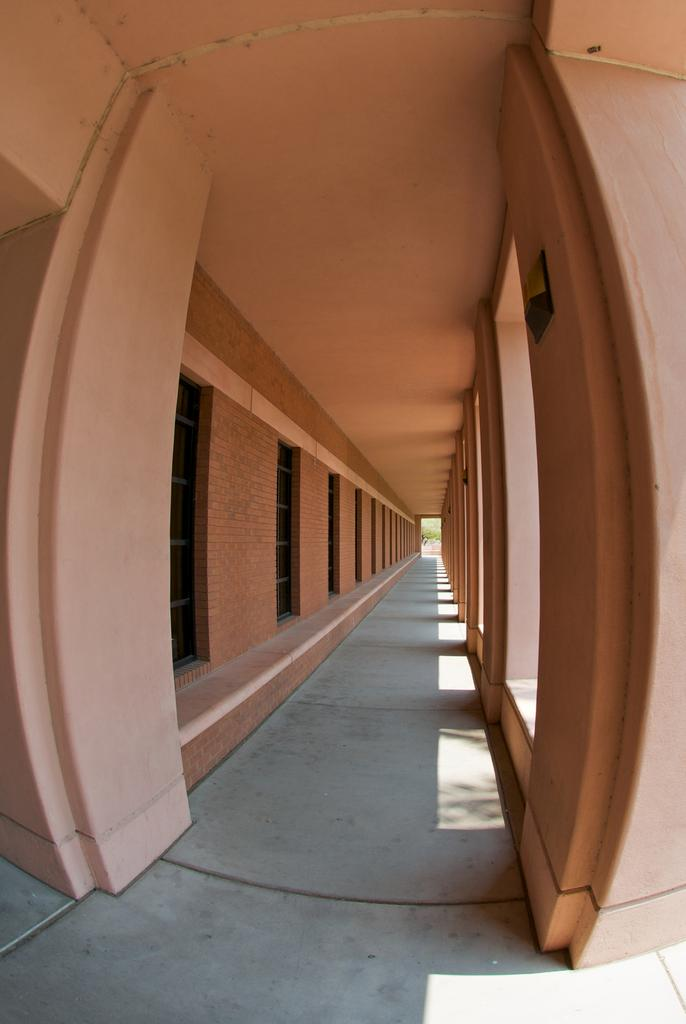What architectural features can be seen in the image? There are windows, a walkway, and pillars visible in the image. What is the color of the pillars in the image? The pillars are pink in color. What is located at the top of the image? There is a roof visible at the top of the image. Can you see a crown on top of the pillars in the image? There is no crown present on top of the pillars in the image. What type of police car can be seen driving on the walkway in the image? There is no police car or any vehicles visible on the walkway in the image. 